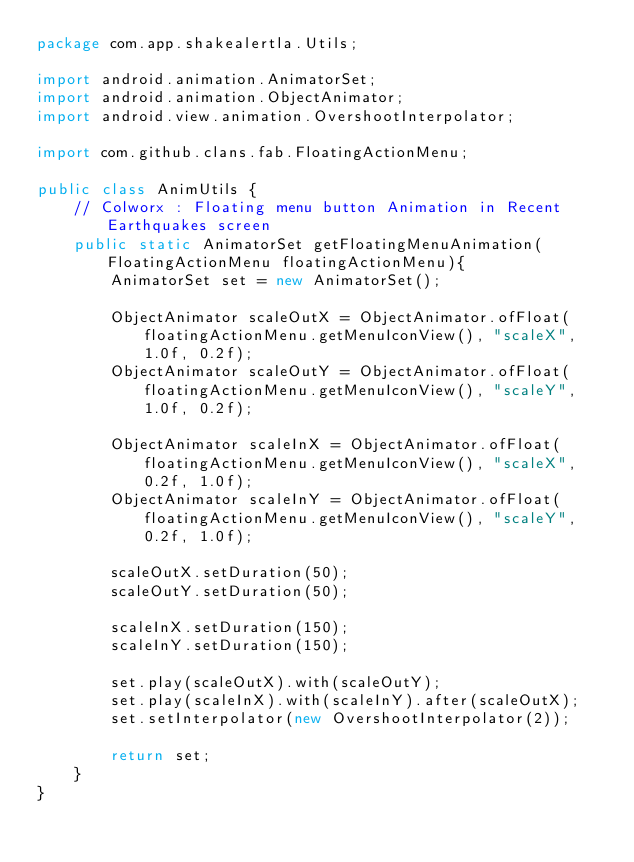Convert code to text. <code><loc_0><loc_0><loc_500><loc_500><_Java_>package com.app.shakealertla.Utils;

import android.animation.AnimatorSet;
import android.animation.ObjectAnimator;
import android.view.animation.OvershootInterpolator;

import com.github.clans.fab.FloatingActionMenu;

public class AnimUtils {
    // Colworx : Floating menu button Animation in Recent Earthquakes screen
    public static AnimatorSet getFloatingMenuAnimation(FloatingActionMenu floatingActionMenu){
        AnimatorSet set = new AnimatorSet();

        ObjectAnimator scaleOutX = ObjectAnimator.ofFloat(floatingActionMenu.getMenuIconView(), "scaleX", 1.0f, 0.2f);
        ObjectAnimator scaleOutY = ObjectAnimator.ofFloat(floatingActionMenu.getMenuIconView(), "scaleY", 1.0f, 0.2f);

        ObjectAnimator scaleInX = ObjectAnimator.ofFloat(floatingActionMenu.getMenuIconView(), "scaleX", 0.2f, 1.0f);
        ObjectAnimator scaleInY = ObjectAnimator.ofFloat(floatingActionMenu.getMenuIconView(), "scaleY", 0.2f, 1.0f);

        scaleOutX.setDuration(50);
        scaleOutY.setDuration(50);

        scaleInX.setDuration(150);
        scaleInY.setDuration(150);

        set.play(scaleOutX).with(scaleOutY);
        set.play(scaleInX).with(scaleInY).after(scaleOutX);
        set.setInterpolator(new OvershootInterpolator(2));

        return set;
    }
}
</code> 